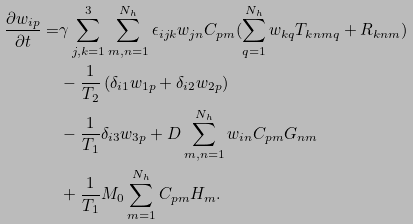Convert formula to latex. <formula><loc_0><loc_0><loc_500><loc_500>\frac { \partial w _ { i p } } { \partial t } = & \gamma \sum _ { j , k = 1 } ^ { 3 } \sum _ { m , n = 1 } ^ { N _ { h } } \epsilon _ { i j k } w _ { j n } C _ { p m } ( \sum _ { q = 1 } ^ { N _ { h } } w _ { k q } T _ { k n m q } + R _ { k n m } ) \\ & - \frac { 1 } { T _ { 2 } } \left ( \delta _ { i 1 } w _ { 1 p } + \delta _ { i 2 } w _ { 2 p } \right ) \\ & - \frac { 1 } { T _ { 1 } } \delta _ { i 3 } w _ { 3 p } + D \sum _ { m , n = 1 } ^ { N _ { h } } w _ { i n } C _ { p m } G _ { n m } \\ & + \frac { 1 } { T _ { 1 } } M _ { 0 } \sum _ { m = 1 } ^ { N _ { h } } C _ { p m } H _ { m } .</formula> 